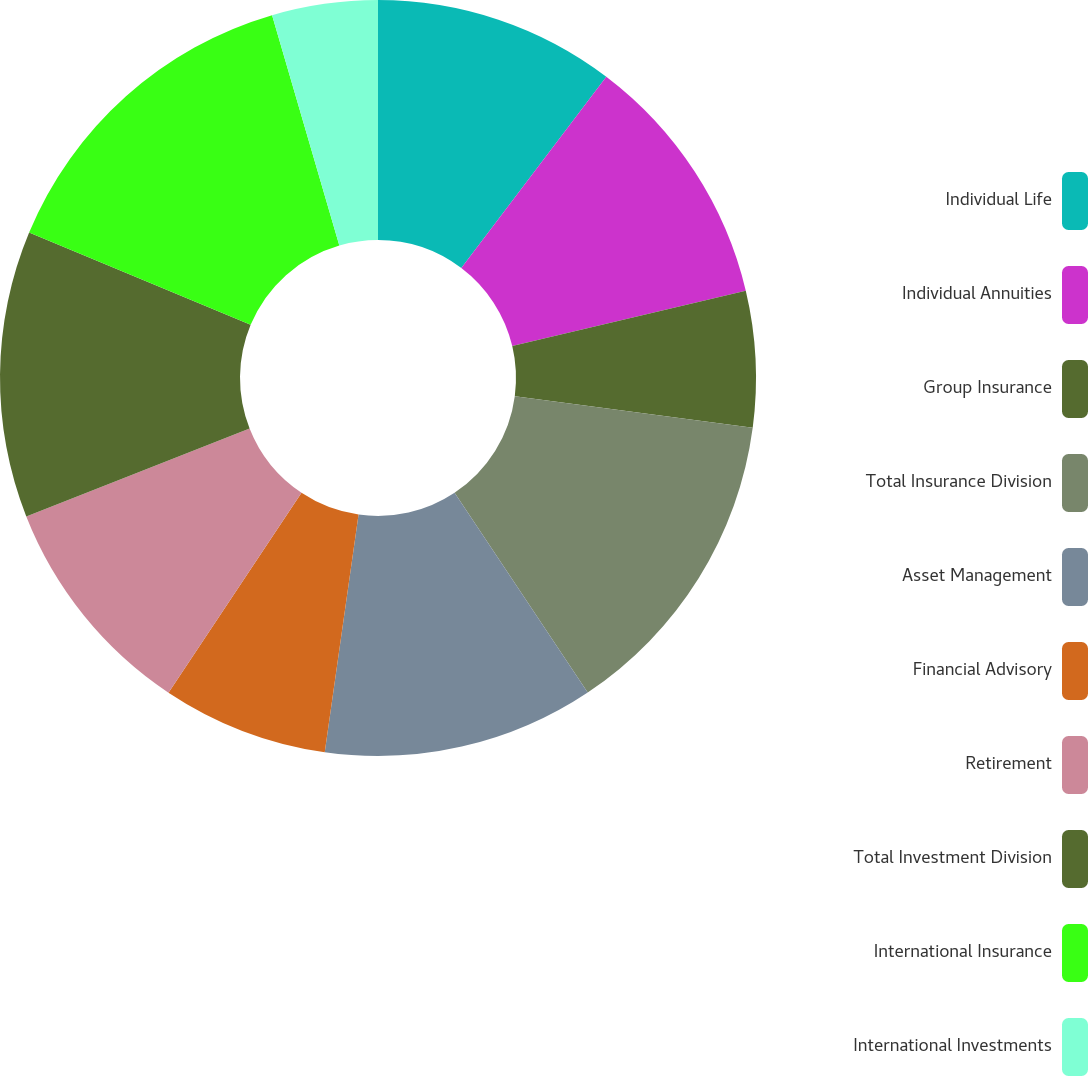Convert chart to OTSL. <chart><loc_0><loc_0><loc_500><loc_500><pie_chart><fcel>Individual Life<fcel>Individual Annuities<fcel>Group Insurance<fcel>Total Insurance Division<fcel>Asset Management<fcel>Financial Advisory<fcel>Retirement<fcel>Total Investment Division<fcel>International Insurance<fcel>International Investments<nl><fcel>10.32%<fcel>10.97%<fcel>5.81%<fcel>13.54%<fcel>11.61%<fcel>7.1%<fcel>9.68%<fcel>12.26%<fcel>14.19%<fcel>4.52%<nl></chart> 